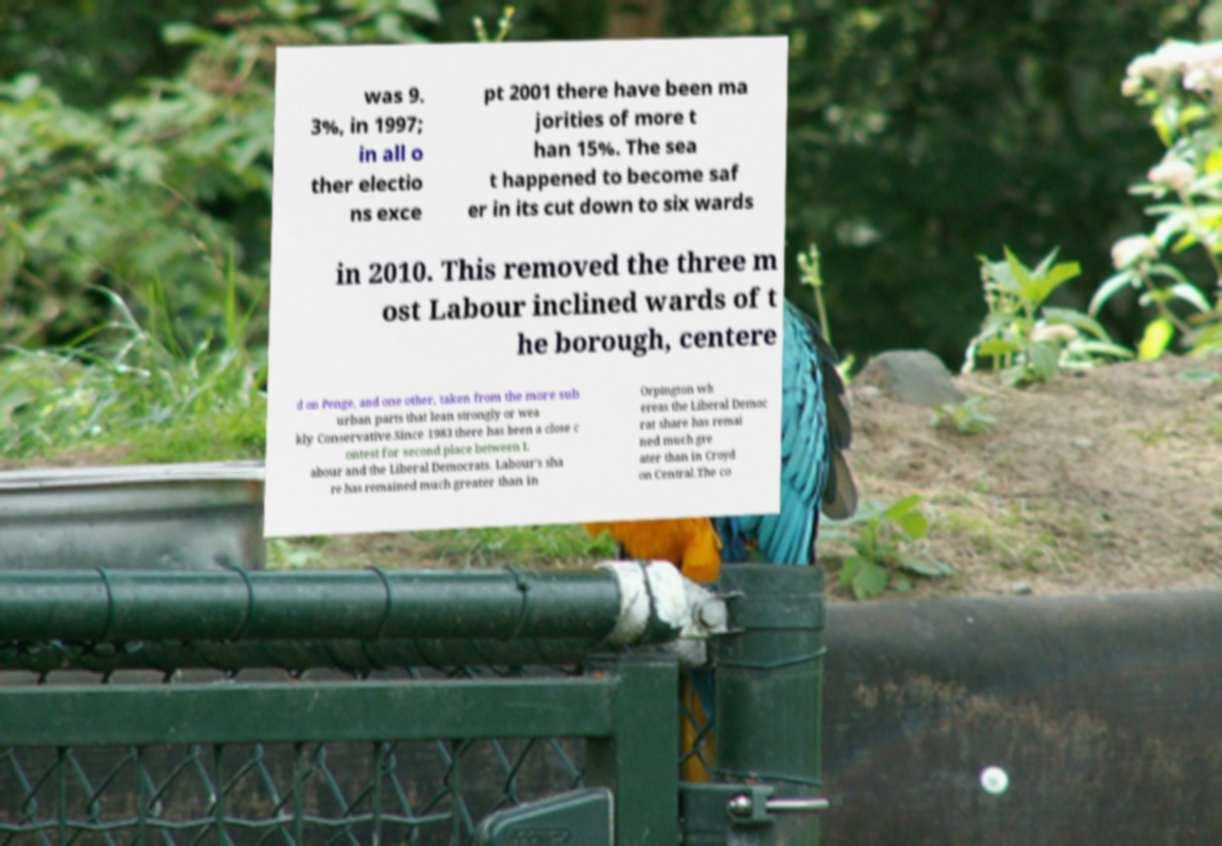I need the written content from this picture converted into text. Can you do that? was 9. 3%, in 1997; in all o ther electio ns exce pt 2001 there have been ma jorities of more t han 15%. The sea t happened to become saf er in its cut down to six wards in 2010. This removed the three m ost Labour inclined wards of t he borough, centere d on Penge, and one other, taken from the more sub urban parts that lean strongly or wea kly Conservative.Since 1983 there has been a close c ontest for second place between L abour and the Liberal Democrats. Labour's sha re has remained much greater than in Orpington wh ereas the Liberal Democ rat share has remai ned much gre ater than in Croyd on Central.The co 